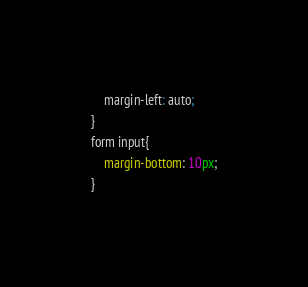Convert code to text. <code><loc_0><loc_0><loc_500><loc_500><_CSS_>    margin-left: auto;
}
form input{
    margin-bottom: 10px;
}</code> 